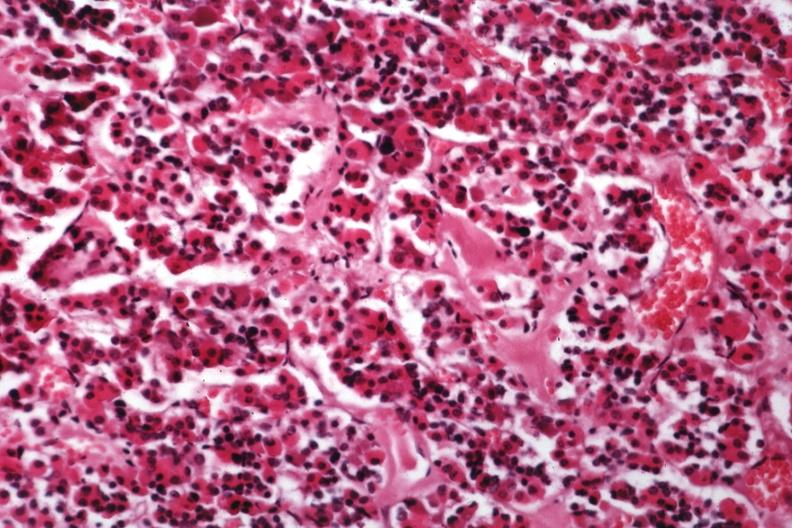does this image show hyalin material in pituitary which is amyloid?
Answer the question using a single word or phrase. Yes 